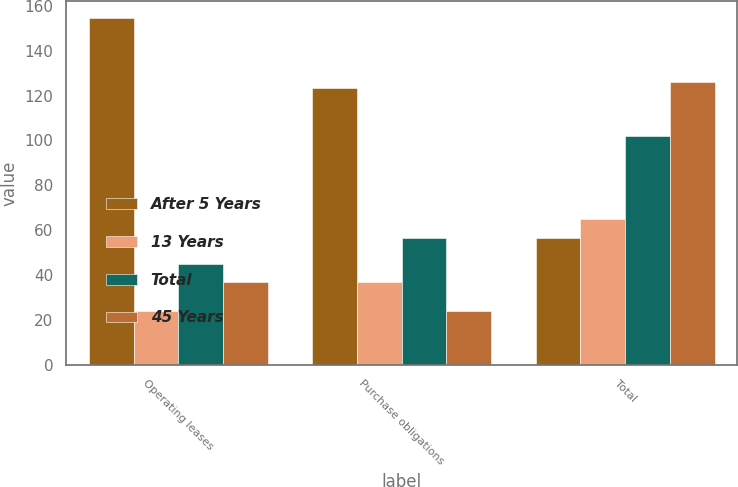<chart> <loc_0><loc_0><loc_500><loc_500><stacked_bar_chart><ecel><fcel>Operating leases<fcel>Purchase obligations<fcel>Total<nl><fcel>After 5 Years<fcel>154.3<fcel>123.5<fcel>56.7<nl><fcel>13 Years<fcel>24<fcel>37.1<fcel>65.2<nl><fcel>Total<fcel>45.1<fcel>56.7<fcel>101.8<nl><fcel>45 Years<fcel>37<fcel>23.9<fcel>126.2<nl></chart> 